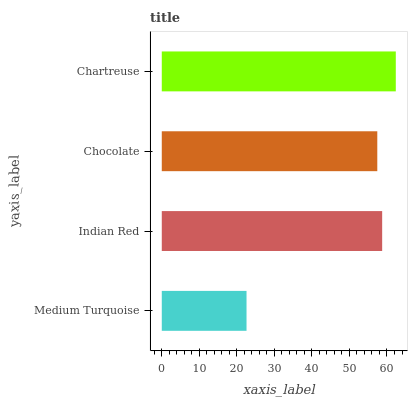Is Medium Turquoise the minimum?
Answer yes or no. Yes. Is Chartreuse the maximum?
Answer yes or no. Yes. Is Indian Red the minimum?
Answer yes or no. No. Is Indian Red the maximum?
Answer yes or no. No. Is Indian Red greater than Medium Turquoise?
Answer yes or no. Yes. Is Medium Turquoise less than Indian Red?
Answer yes or no. Yes. Is Medium Turquoise greater than Indian Red?
Answer yes or no. No. Is Indian Red less than Medium Turquoise?
Answer yes or no. No. Is Indian Red the high median?
Answer yes or no. Yes. Is Chocolate the low median?
Answer yes or no. Yes. Is Chartreuse the high median?
Answer yes or no. No. Is Medium Turquoise the low median?
Answer yes or no. No. 